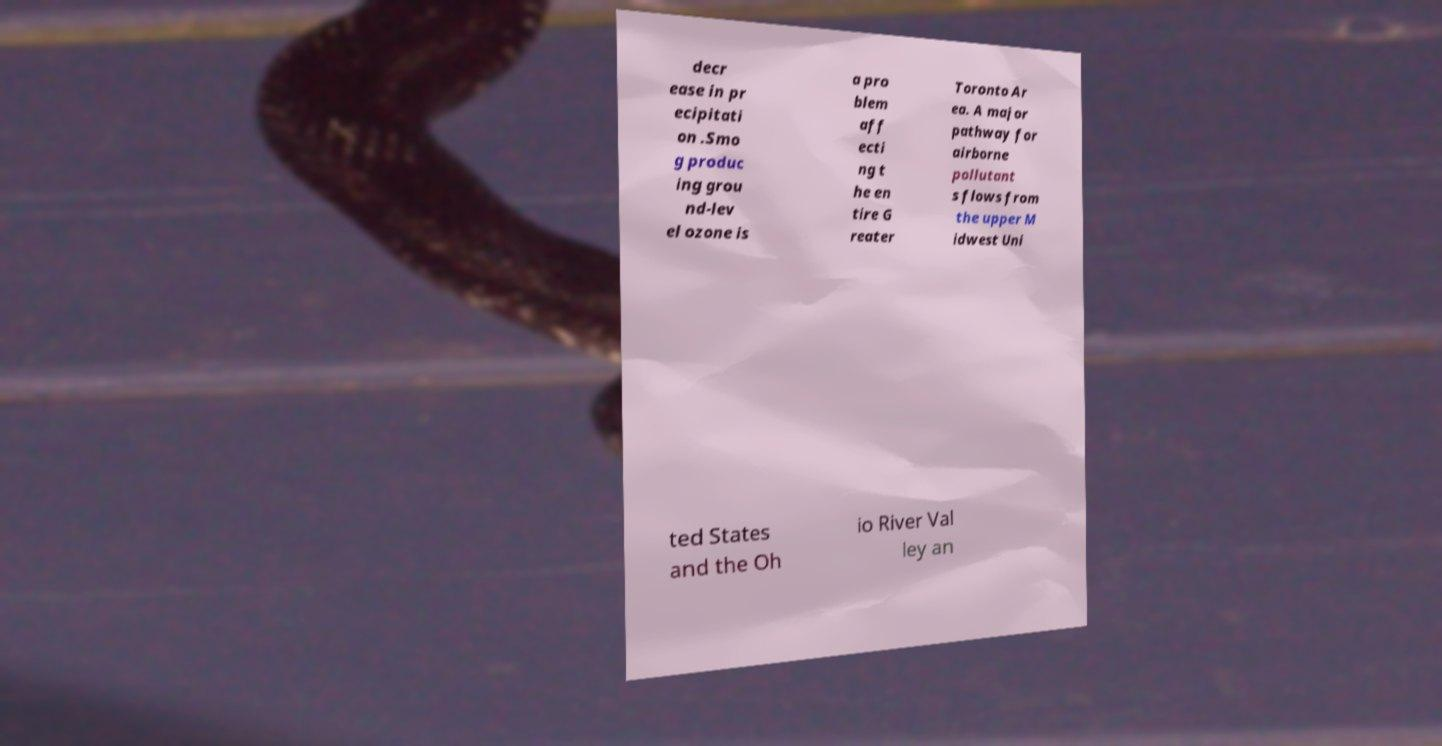For documentation purposes, I need the text within this image transcribed. Could you provide that? decr ease in pr ecipitati on .Smo g produc ing grou nd-lev el ozone is a pro blem aff ecti ng t he en tire G reater Toronto Ar ea. A major pathway for airborne pollutant s flows from the upper M idwest Uni ted States and the Oh io River Val ley an 